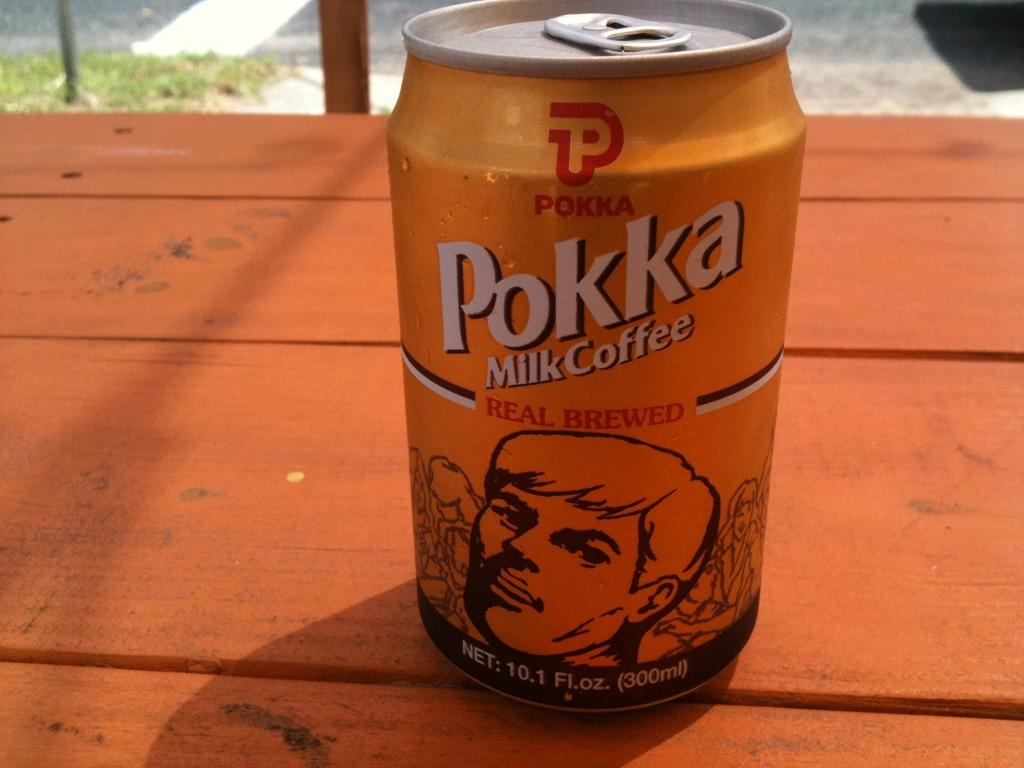<image>
Share a concise interpretation of the image provided. Orange can of beer that reads Pokka on a wooden table. 